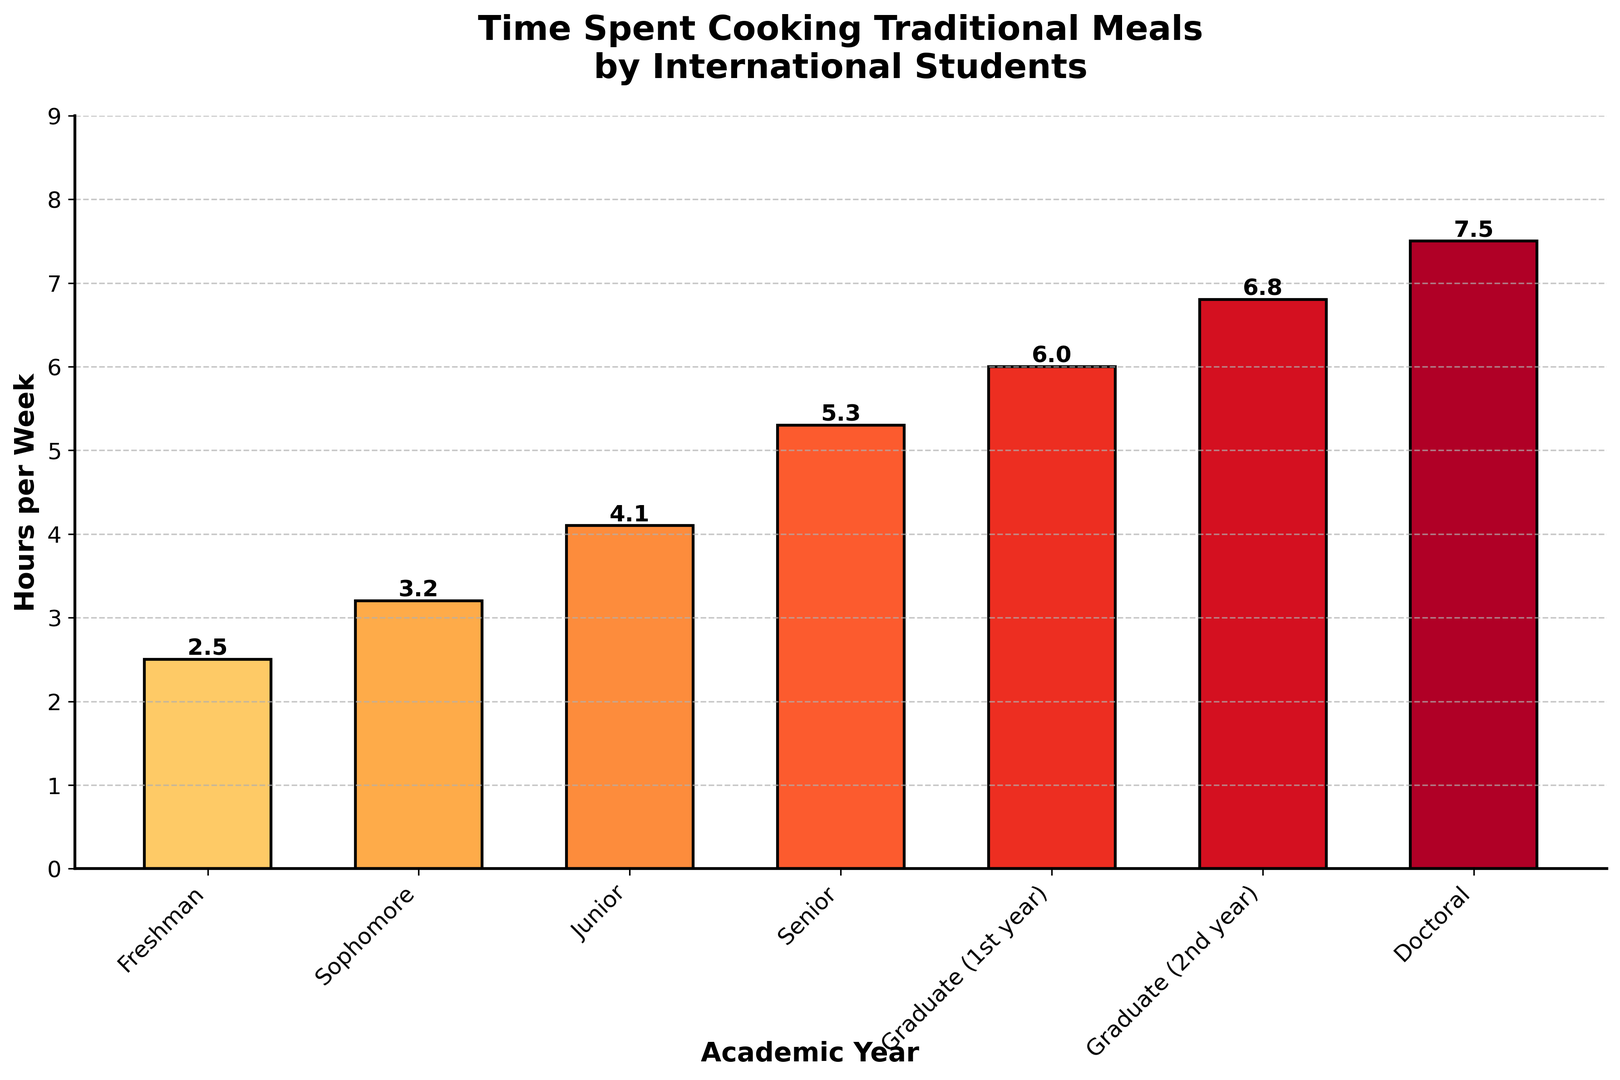What's the average time spent cooking traditional meals per week by students in their undergraduate years? To find the average, first sum the hours spent by Freshman (2.5), Sophomore (3.2), Junior (4.1), and Senior (5.3). The total is 2.5 + 3.2 + 4.1 + 5.3 = 15.1 hours. There are 4 different academic years, so the average is 15.1 / 4.
Answer: 3.775 hours How much more time do Doctoral students spend cooking traditional meals compared to Freshmen? The time Doctoral students spend is 7.5 hours, and the time Freshmen spend is 2.5 hours. The difference is 7.5 - 2.5.
Answer: 5 hours Among Graduate (1st year) and Graduate (2nd year) students, who spends more time cooking traditional meals, and by how much? Graduate (2nd year) students spend 6.8 hours, while Graduate (1st year) students spend 6.0 hours. The difference is 6.8 - 6.0.
Answer: Graduate (2nd year) by 0.8 hours Which academic year shows the highest amount of time spent cooking traditional meals, and how many hours is it? From the visual, Doctoral students spend the highest amount of time, which is 7.5 hours.
Answer: Doctoral, 7.5 hours Is the increase in hours spent cooking traditional meals from Freshman to Sophomore greater or less than the increase from Senior to Graduate (1st year)? The increase from Freshman (2.5) to Sophomore (3.2) is 3.2 - 2.5 = 0.7 hours. The increase from Senior (5.3) to Graduate (1st year) (6.0) is 6.0 - 5.3 = 0.7 hours.
Answer: Equal, 0.7 hours Does the amount of time spent cooking traditional meals continuously increase each year? Observing the bars, each subsequent year shows a higher bar than the previous one, indicating a continuous increase.
Answer: Yes What's the combined time spent cooking traditional meals by Graduate (1st year) and Graduate (2nd year) students? Graduate (1st year) students spend 6.0 hours, and Graduate (2nd year) students spend 6.8 hours. The combined time is 6.0 + 6.8.
Answer: 12.8 hours Compare the total time spent cooking traditional meals by undergraduate and graduate students. Which group spends more time and by how much? Sum the hours for undergraduate years (2.5 + 3.2 + 4.1 + 5.3 = 15.1 hours) and for graduate years (6.0 + 6.8 + 7.5 = 20.3 hours). Graduate students spend 20.3 - 15.1 more hours than undergraduates.
Answer: Graduates by 5.2 hours Which academic year has the shortest bar, and what is the corresponding time spent cooking traditional meals? The shortest bar corresponds to the Freshman year, which denotes 2.5 hours.
Answer: Freshman, 2.5 hours What is the median time spent cooking traditional meals among all the academic years? Arrange the hours in ascending order: 2.5, 3.2, 4.1, 5.3, 6.0, 6.8, 7.5. The median is the middle value, which is the 4th value in this list.
Answer: 5.3 hours 